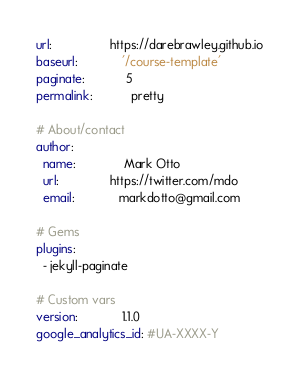<code> <loc_0><loc_0><loc_500><loc_500><_YAML_>url:                 https://darebrawley.github.io
baseurl:             '/course-template'
paginate:            5
permalink:           pretty

# About/contact
author:
  name:              Mark Otto
  url:               https://twitter.com/mdo
  email:             markdotto@gmail.com

# Gems
plugins:
  - jekyll-paginate

# Custom vars
version:             1.1.0
google_analytics_id: #UA-XXXX-Y
</code> 